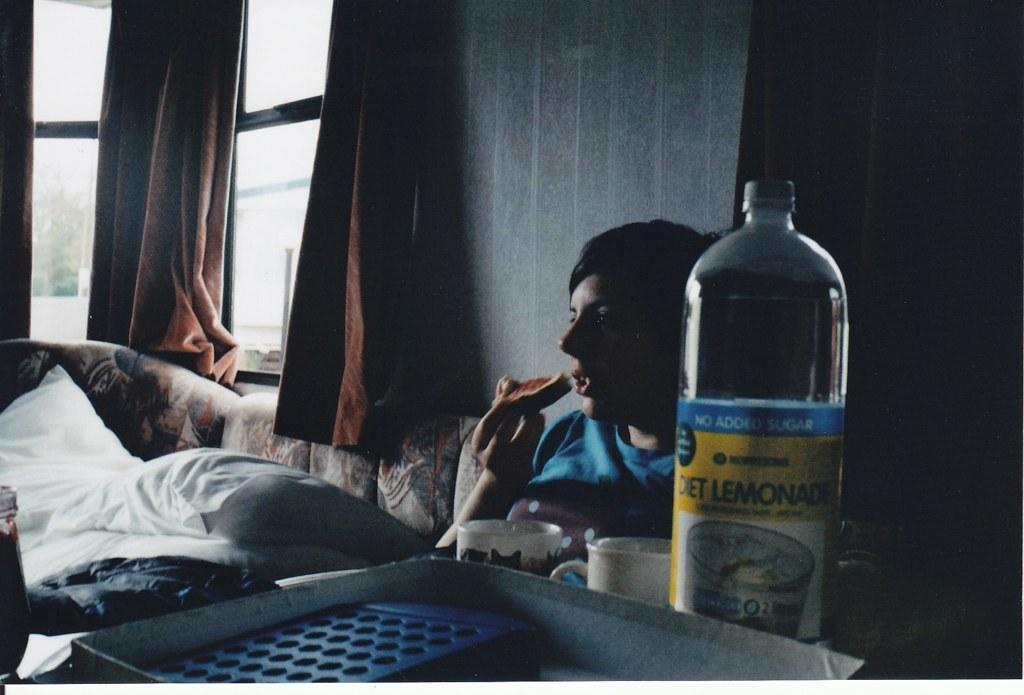What are the men in the image doing? The men in the image are sitting on a sofa and eating bread. What can be seen on the table in the image? There is a cup, a bottle, and a tray on the table in the image. What is the purpose of the curtains in the image? The curtains on the window in the image provide privacy and may help control the amount of light entering the room. What might be used for additional comfort while sitting on the sofa? There are pillows on the sofa in the image. Can you tell me how many cattle are present in the image? There are no cattle present in the image; it features men sitting on a sofa and eating bread, along with various items on a table and a window with curtains. 